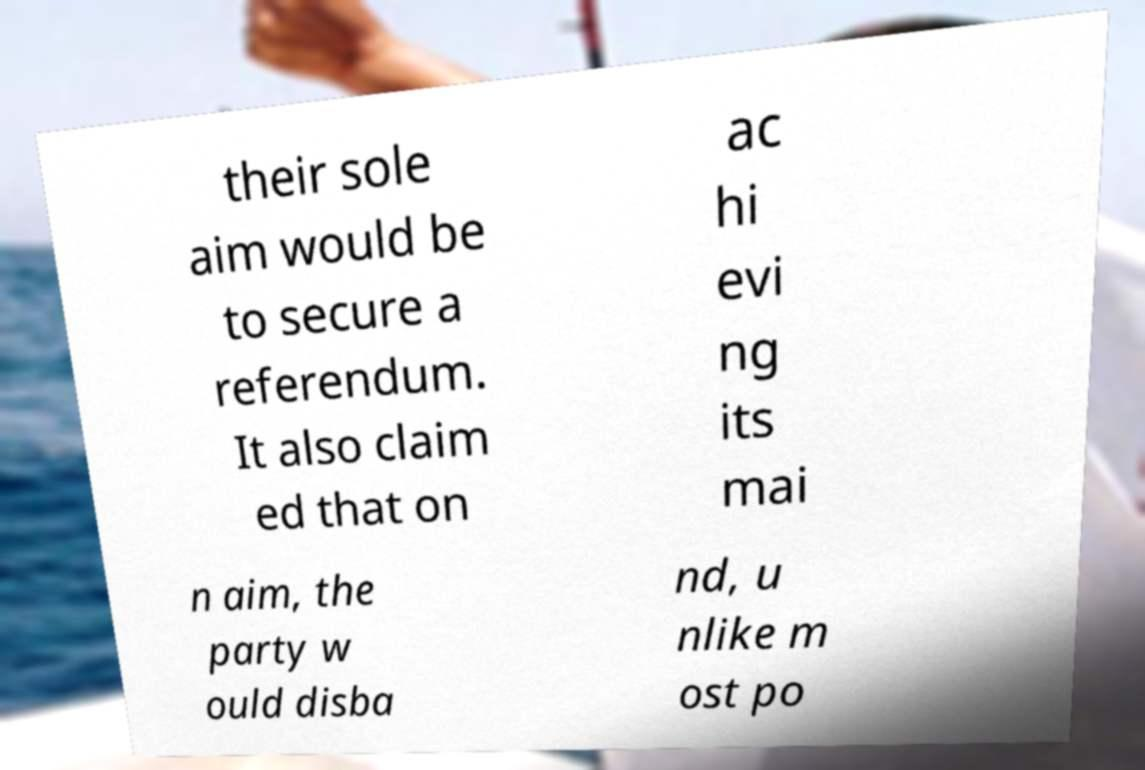Can you read and provide the text displayed in the image?This photo seems to have some interesting text. Can you extract and type it out for me? their sole aim would be to secure a referendum. It also claim ed that on ac hi evi ng its mai n aim, the party w ould disba nd, u nlike m ost po 